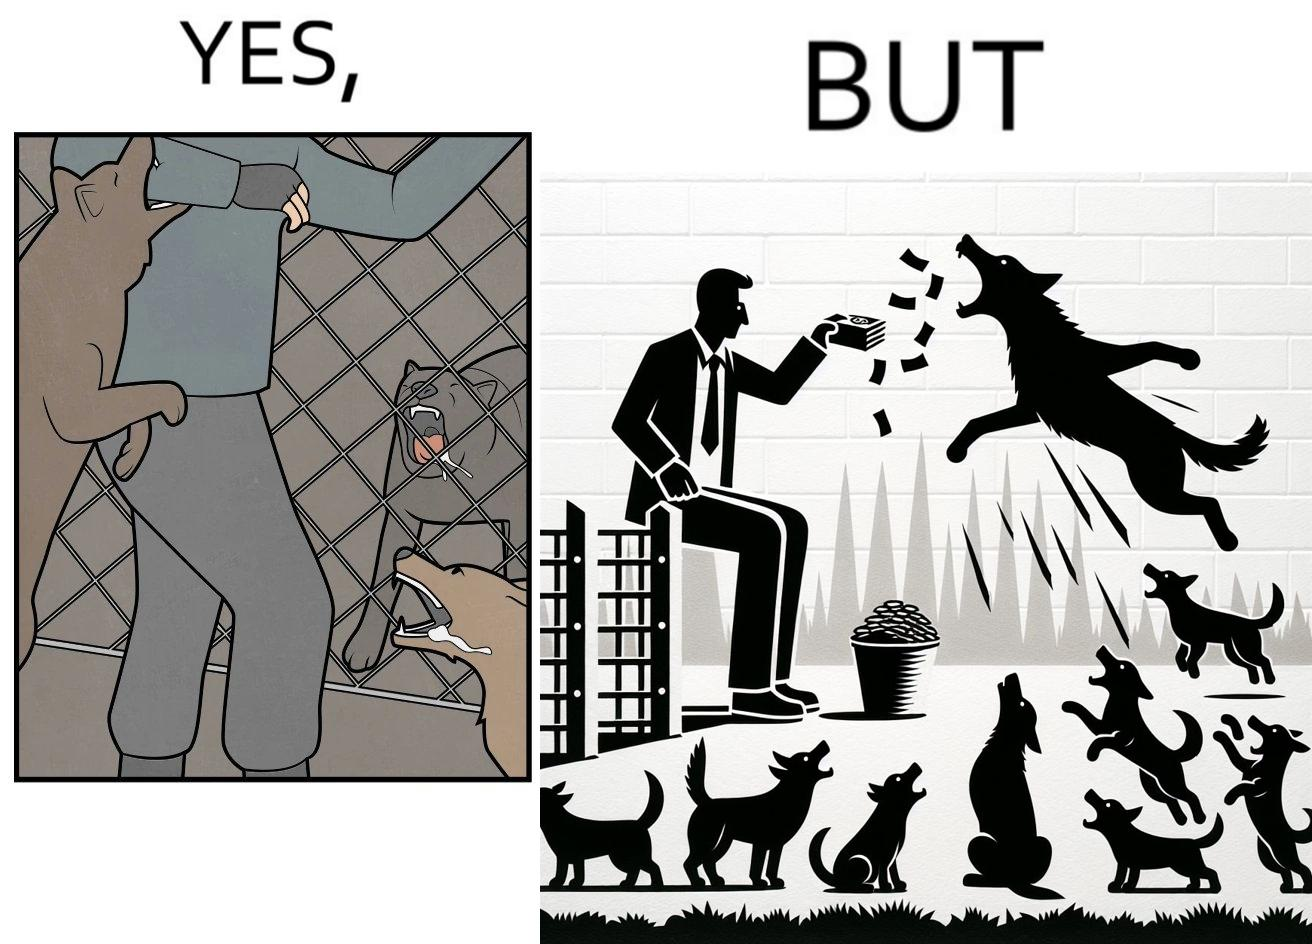Describe what you see in this image. The images are ironic since they show how dogs choose to attack a well wisher making a donation for helping dogs. It is sad that dogs mistake a well wisher and bite him while he is trying to help them. 